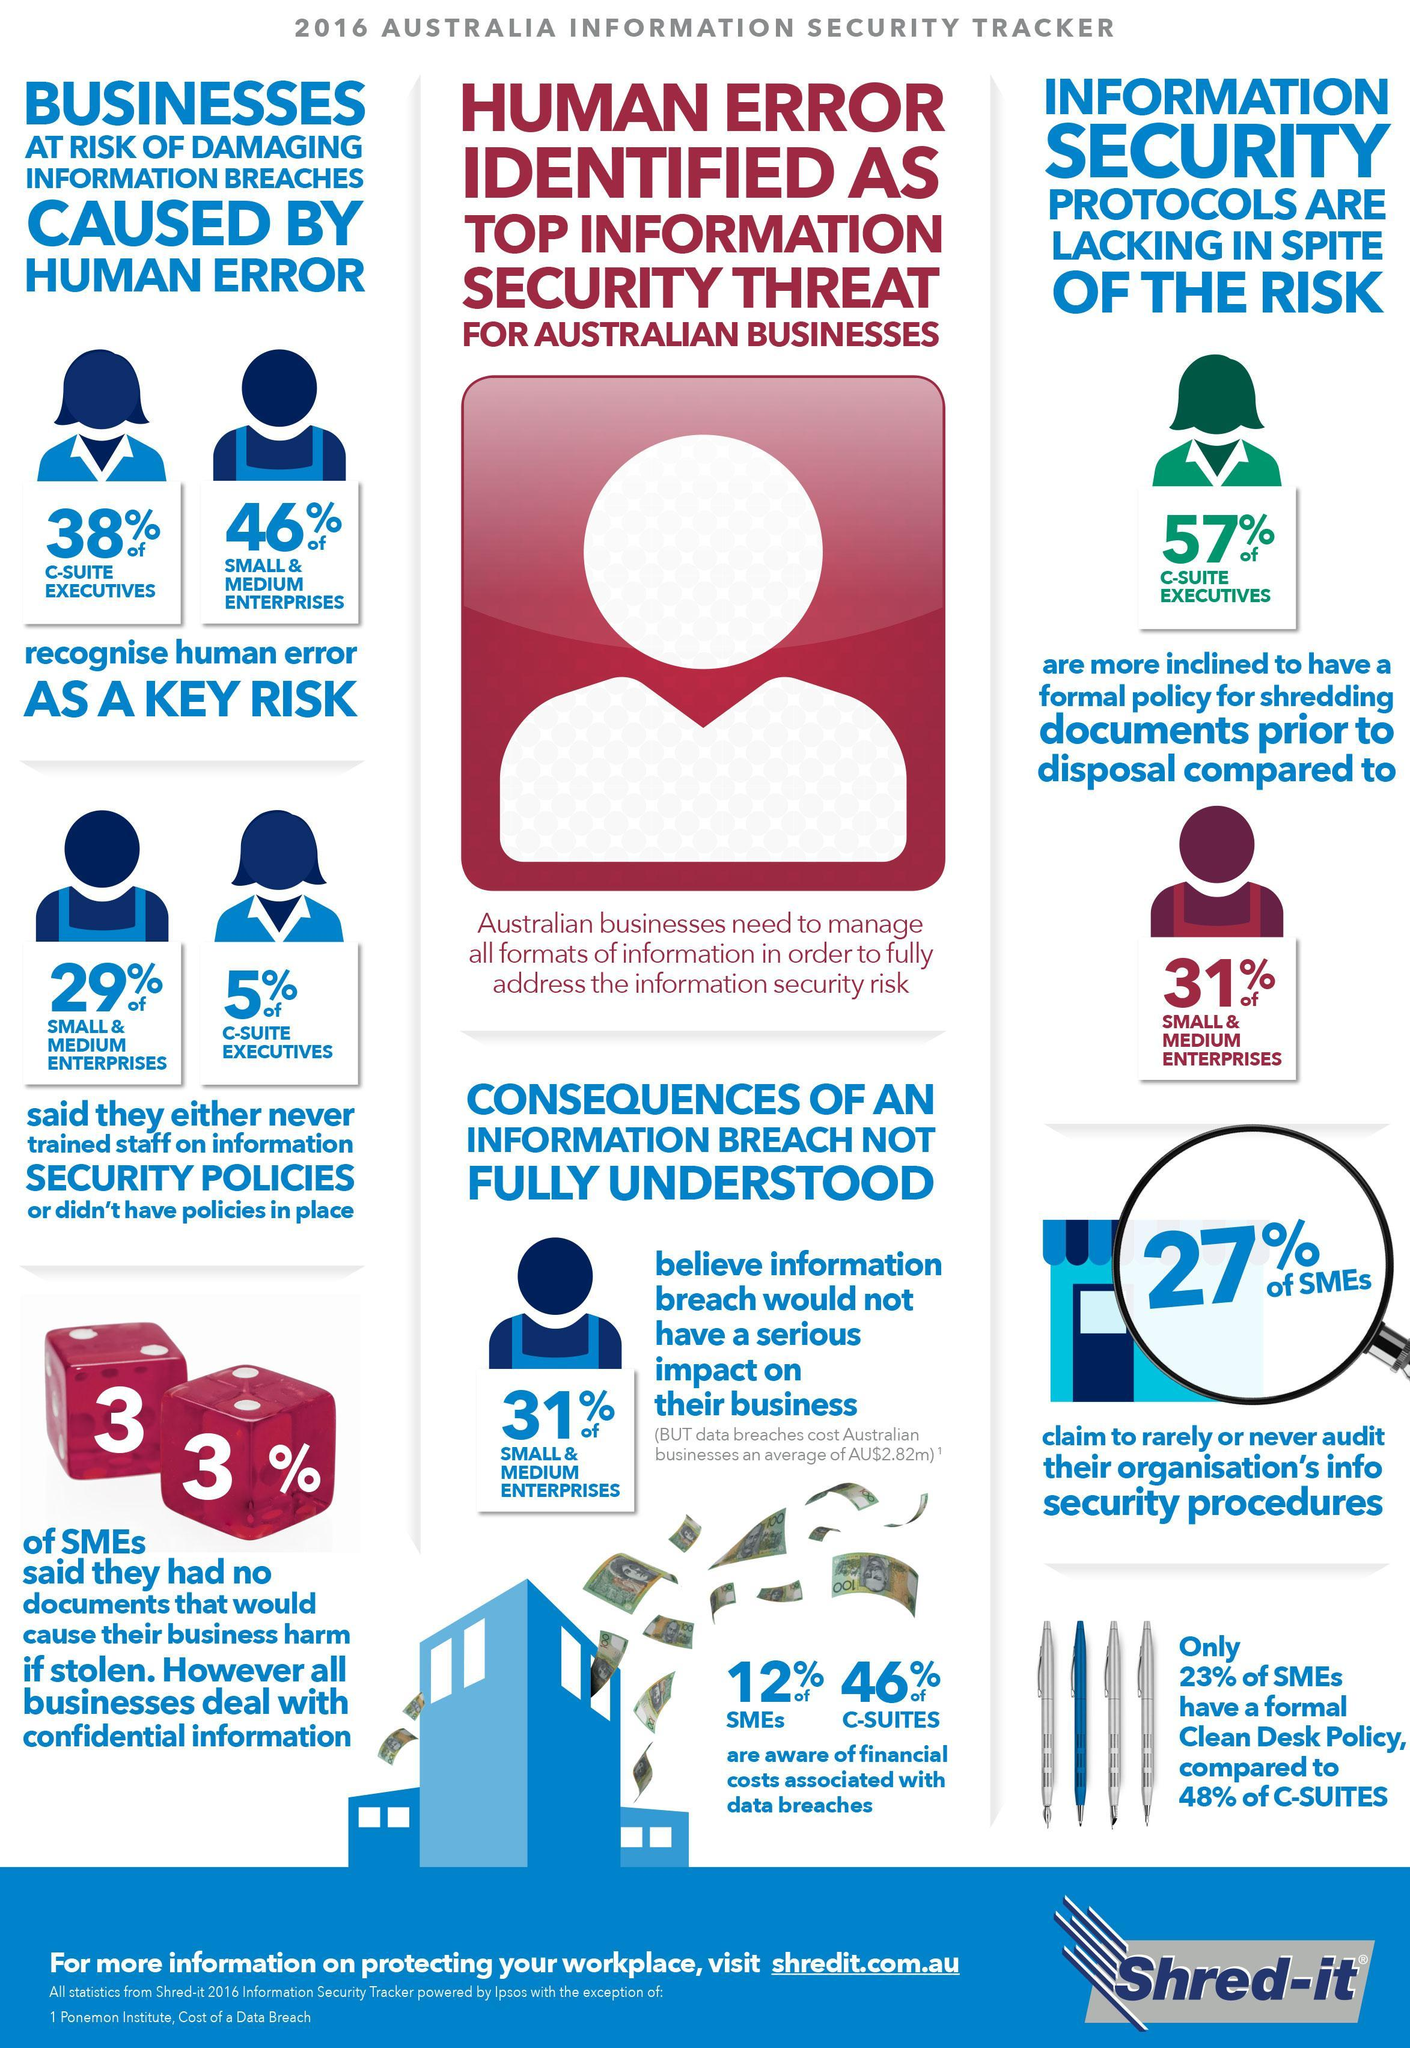What percentage of C-suite executives do not recognise human error as a key risk in Australia in 2016?
Answer the question with a short phrase. 62% What percentage of small & medium enterprises recognise human error as a key risk in Australia in 2016? 46% What percentage of SME's  claim to rarely or never audit their organisation's info security procedures in Australia in 2016? 27% What percentage of C-Suites have a formal clean desk policy in Australia in 2016? 48% What percentage of SME's said they had no documents that would cause their business harm if stolen in Australia in 2016? 33% What percentage of small & medium enterprises believe information breach would not have a serious impact on their business in Australia in 2016? 31% What percentage of SME's are aware of financial costs associated with data breaches in Australia in 2016? 12% 